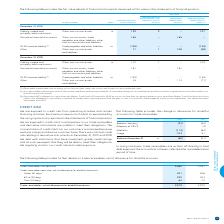According to Bce's financial document, When are trade receivables written off directly to bad debt expense? if the account has not been collected after a predetermined period of time. The document states: "bles are written off directly to bad debt expense if the account has not been collected after a predetermined period of time...." Also, What is the amount of trade receivables not past due in 2019? According to the financial document, 2,082. The relevant text states: "Trade receivables not past due 2,082 2,091..." Also, What segments does the trade receivables past due, net of allowance for doubtful accounts consist of? The document contains multiple relevant values: Under 60 days, 60 to 120 days, Over 120 days. From the document: "Over 120 days 64 72 60 to 120 days 232 304 Under 60 days 541 508..." Also, can you calculate: What is the total Trade receivables past due, net of allowance for doubtful accounts for 2019? Based on the calculation: 541+232+64, the result is 837. This is based on the information: "Over 120 days 64 72 60 to 120 days 232 304 Under 60 days 541 508..." The key data points involved are: 232, 541, 64. Also, can you calculate: What is the change in trade receivables not past due in 2019? Based on the calculation: 2,082-2,091, the result is -9. This is based on the information: "Trade receivables not past due 2,082 2,091 Trade receivables not past due 2,082 2,091..." The key data points involved are: 2,082, 2,091. Also, can you calculate: What is the percentage of trade receivables past due, net of allowance for doubtful accounts out of the total trade receivables, net of allowance for doubtful accounts in 2019? To answer this question, I need to perform calculations using the financial data. The calculation is: (541+232+64)/2,919, which equals 28.67 (percentage). This is based on the information: "Over 120 days 64 72 60 to 120 days 232 304 Under 60 days 541 508 ceivables, net of allowance for doubtful accounts 2,919 2,975..." The key data points involved are: 2,919, 232, 541. 